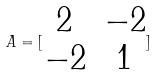Convert formula to latex. <formula><loc_0><loc_0><loc_500><loc_500>A = [ \begin{matrix} 2 & - 2 \\ - 2 & 1 \end{matrix} ]</formula> 